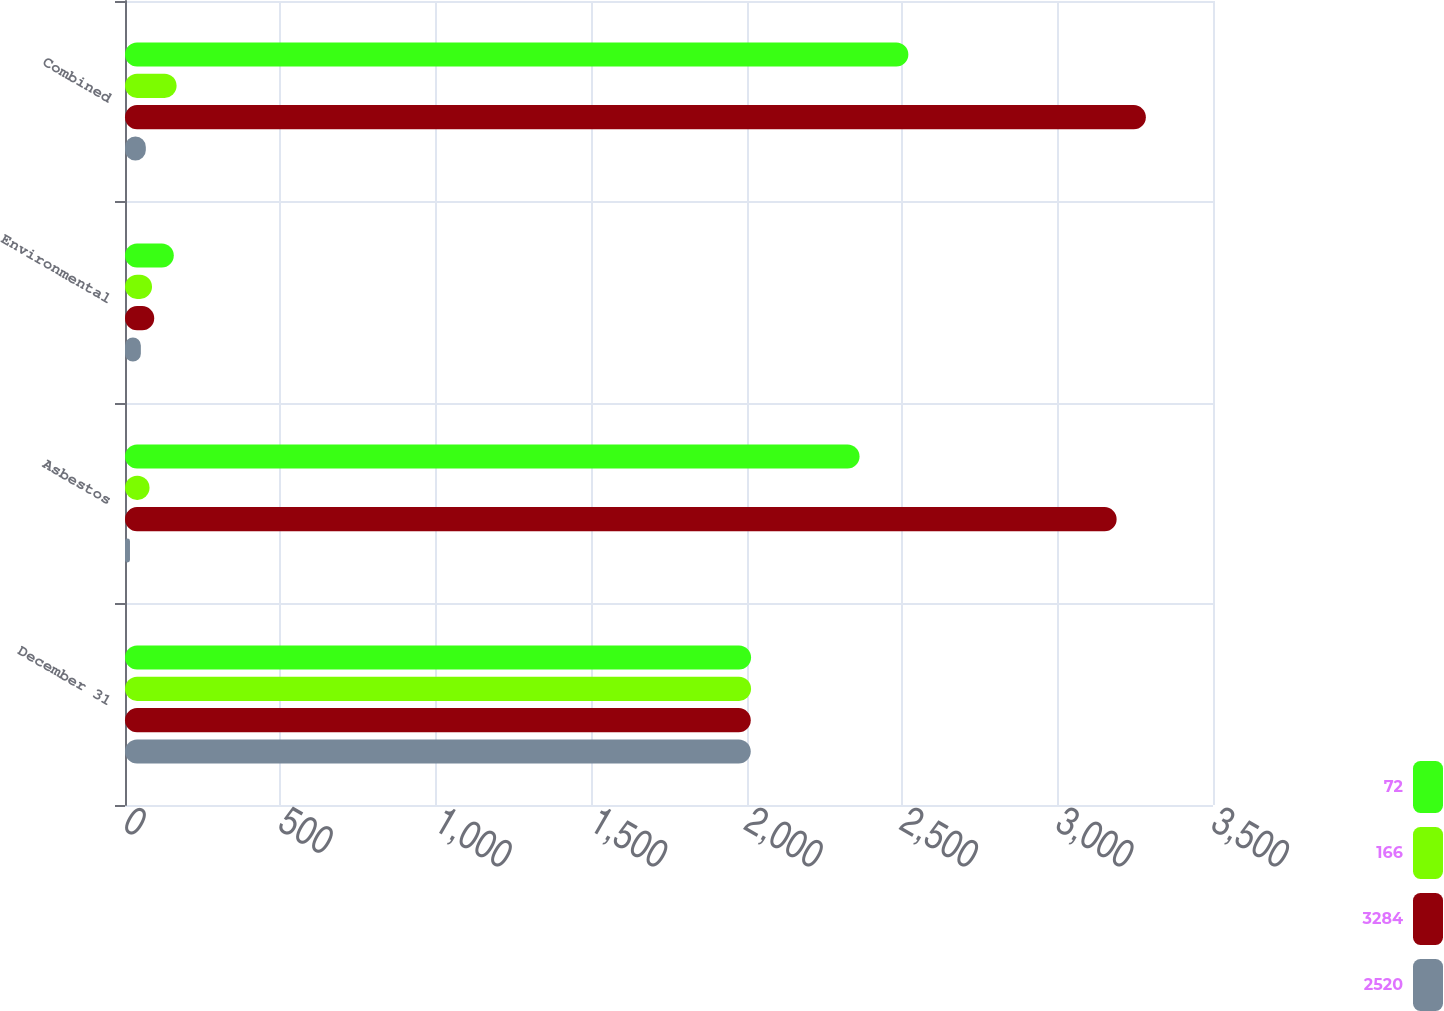Convert chart. <chart><loc_0><loc_0><loc_500><loc_500><stacked_bar_chart><ecel><fcel>December 31<fcel>Asbestos<fcel>Environmental<fcel>Combined<nl><fcel>72<fcel>2014<fcel>2363<fcel>157<fcel>2520<nl><fcel>166<fcel>2014<fcel>79<fcel>87<fcel>166<nl><fcel>3284<fcel>2013<fcel>3190<fcel>94<fcel>3284<nl><fcel>2520<fcel>2013<fcel>16<fcel>51<fcel>67<nl></chart> 